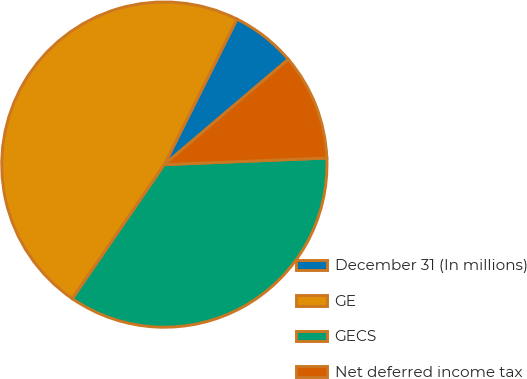Convert chart. <chart><loc_0><loc_0><loc_500><loc_500><pie_chart><fcel>December 31 (In millions)<fcel>GE<fcel>GECS<fcel>Net deferred income tax<nl><fcel>6.43%<fcel>47.8%<fcel>35.21%<fcel>10.56%<nl></chart> 